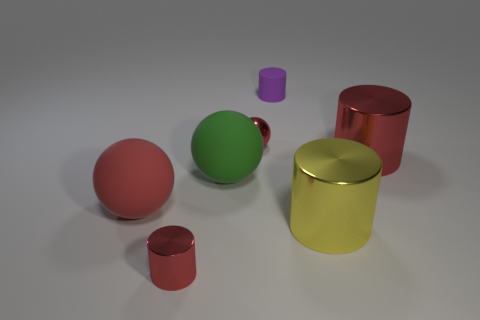How many cylinders are either yellow objects or large red metallic objects?
Provide a succinct answer. 2. Does the big green thing have the same material as the purple cylinder?
Provide a short and direct response. Yes. There is a red shiny thing that is the same shape as the big green object; what is its size?
Make the answer very short. Small. There is a small thing that is on the right side of the large green rubber ball and in front of the small purple cylinder; what is it made of?
Offer a very short reply. Metal. Is the number of shiny things that are right of the tiny red ball the same as the number of big metal cubes?
Offer a very short reply. No. What number of objects are big metal cylinders behind the large green rubber sphere or large balls?
Your answer should be very brief. 3. There is a object right of the big yellow cylinder; does it have the same color as the rubber cylinder?
Provide a succinct answer. No. There is a matte thing that is right of the shiny sphere; what size is it?
Ensure brevity in your answer.  Small. There is a large red object to the left of the cylinder left of the small matte thing; what shape is it?
Make the answer very short. Sphere. There is another rubber thing that is the same shape as the big green matte thing; what color is it?
Provide a short and direct response. Red. 